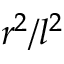Convert formula to latex. <formula><loc_0><loc_0><loc_500><loc_500>r ^ { 2 } / l ^ { 2 }</formula> 